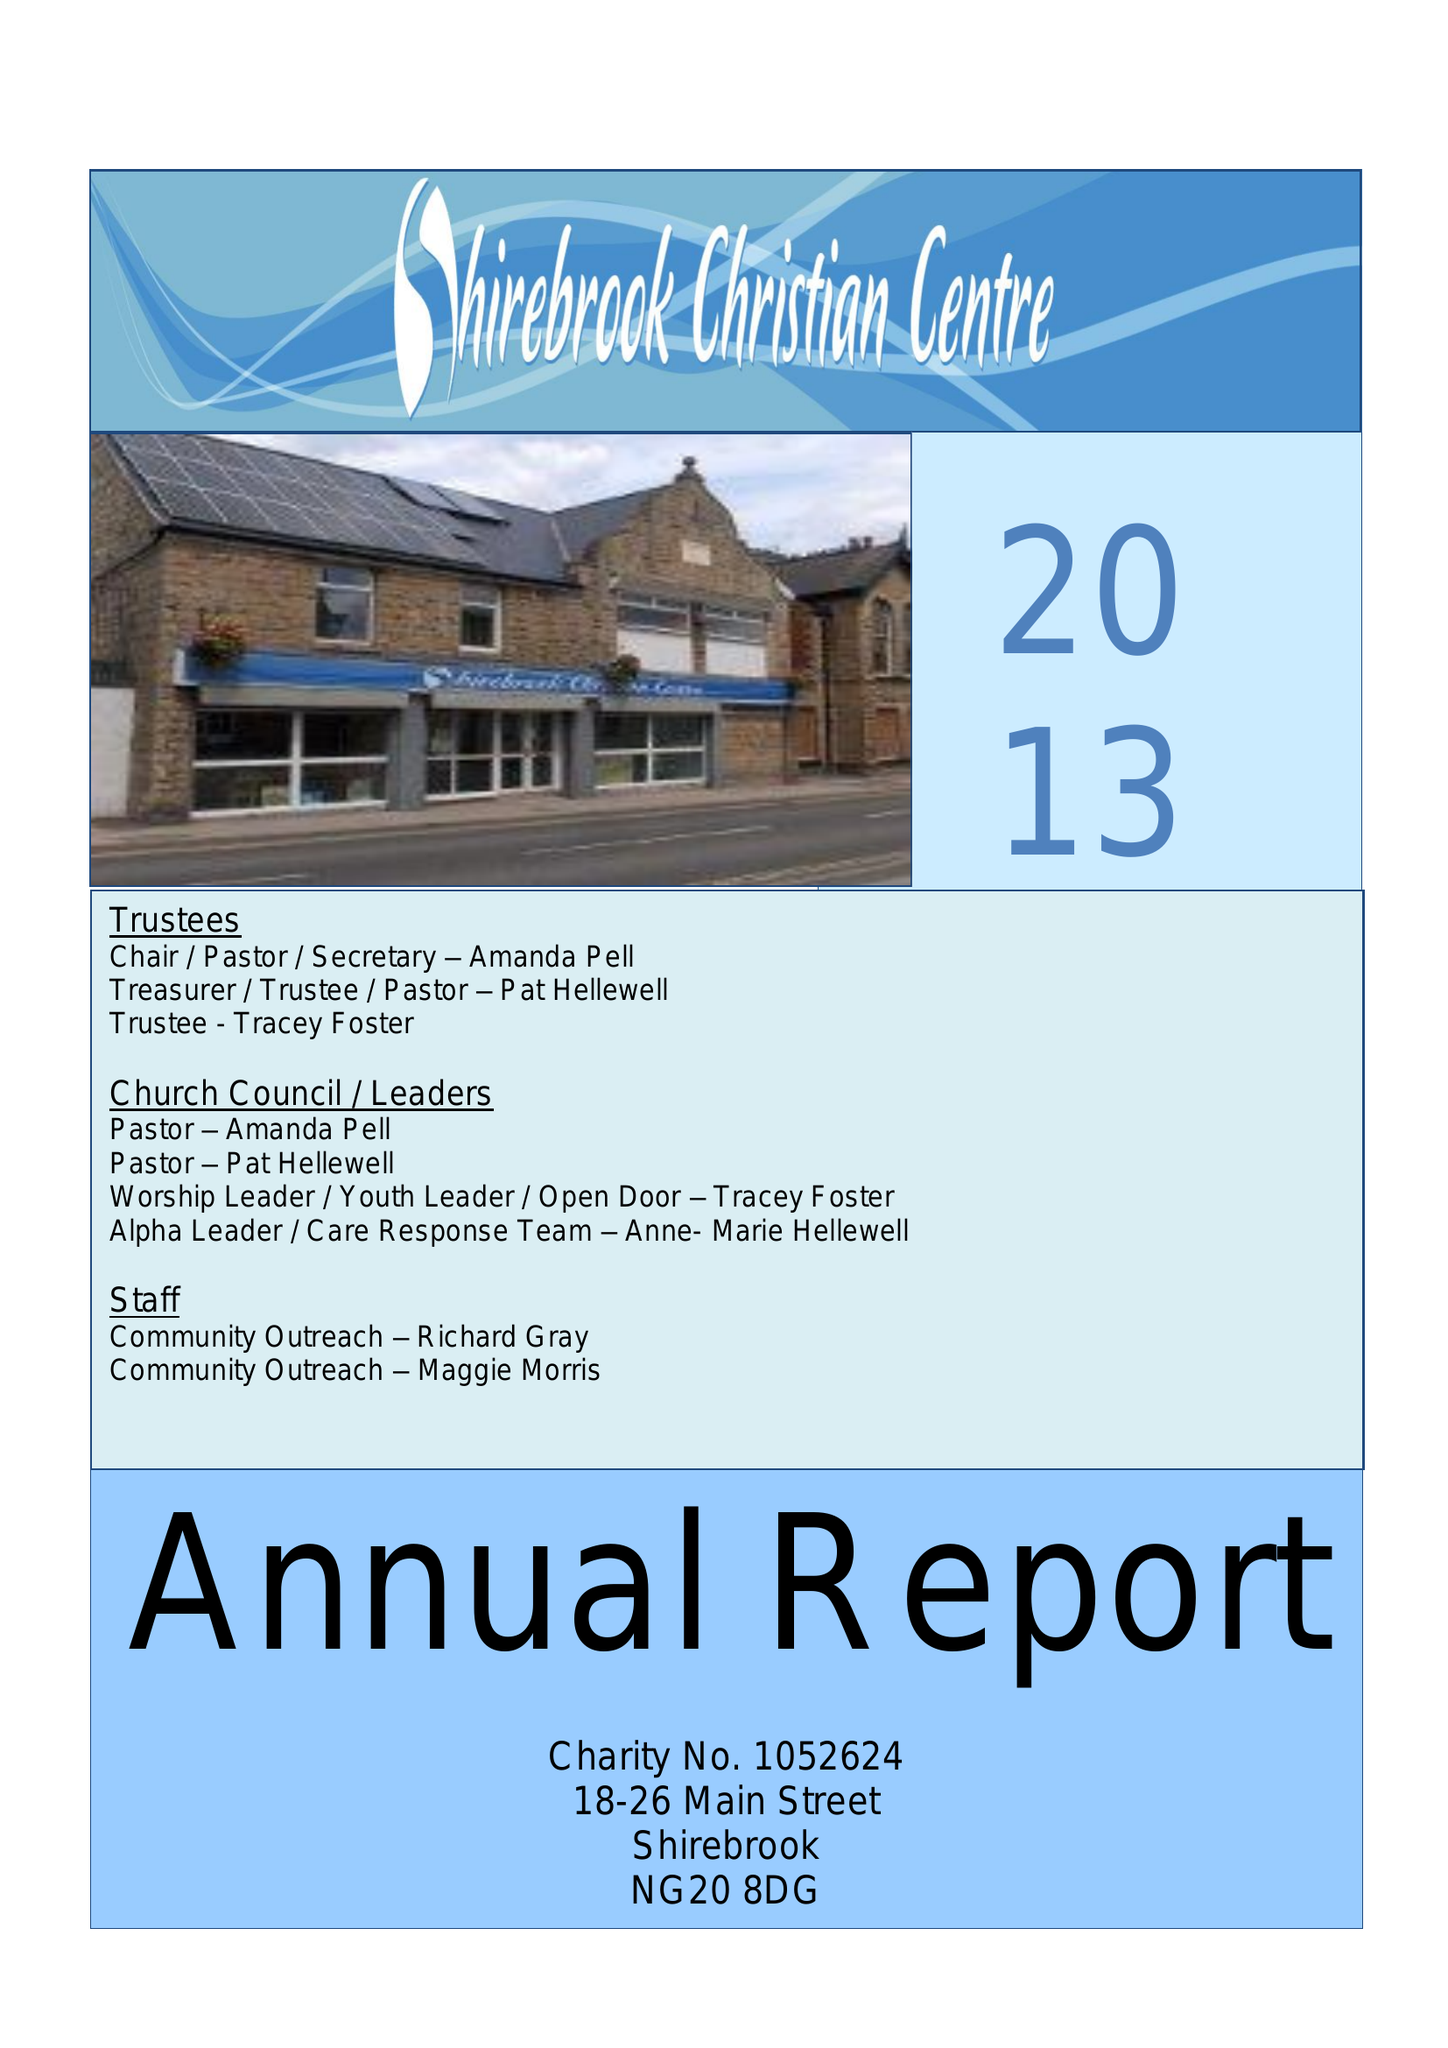What is the value for the income_annually_in_british_pounds?
Answer the question using a single word or phrase. 75346.00 